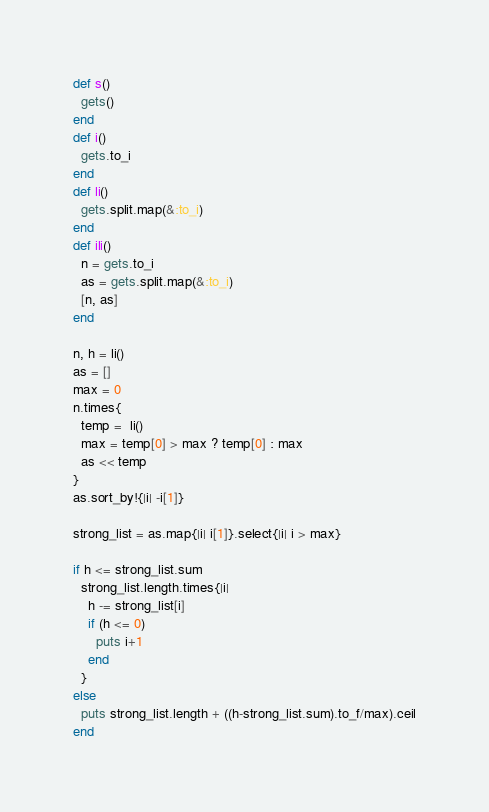<code> <loc_0><loc_0><loc_500><loc_500><_Ruby_>def s()
  gets()
end
def i()
  gets.to_i
end
def li()
  gets.split.map(&:to_i)
end
def ili()
  n = gets.to_i
  as = gets.split.map(&:to_i)
  [n, as]
end

n, h = li()
as = []
max = 0
n.times{
  temp =  li()
  max = temp[0] > max ? temp[0] : max
  as << temp
}
as.sort_by!{|i| -i[1]}

strong_list = as.map{|i| i[1]}.select{|i| i > max}

if h <= strong_list.sum
  strong_list.length.times{|i|
    h -= strong_list[i]
    if (h <= 0)
      puts i+1
    end
  }
else
  puts strong_list.length + ((h-strong_list.sum).to_f/max).ceil
end

</code> 